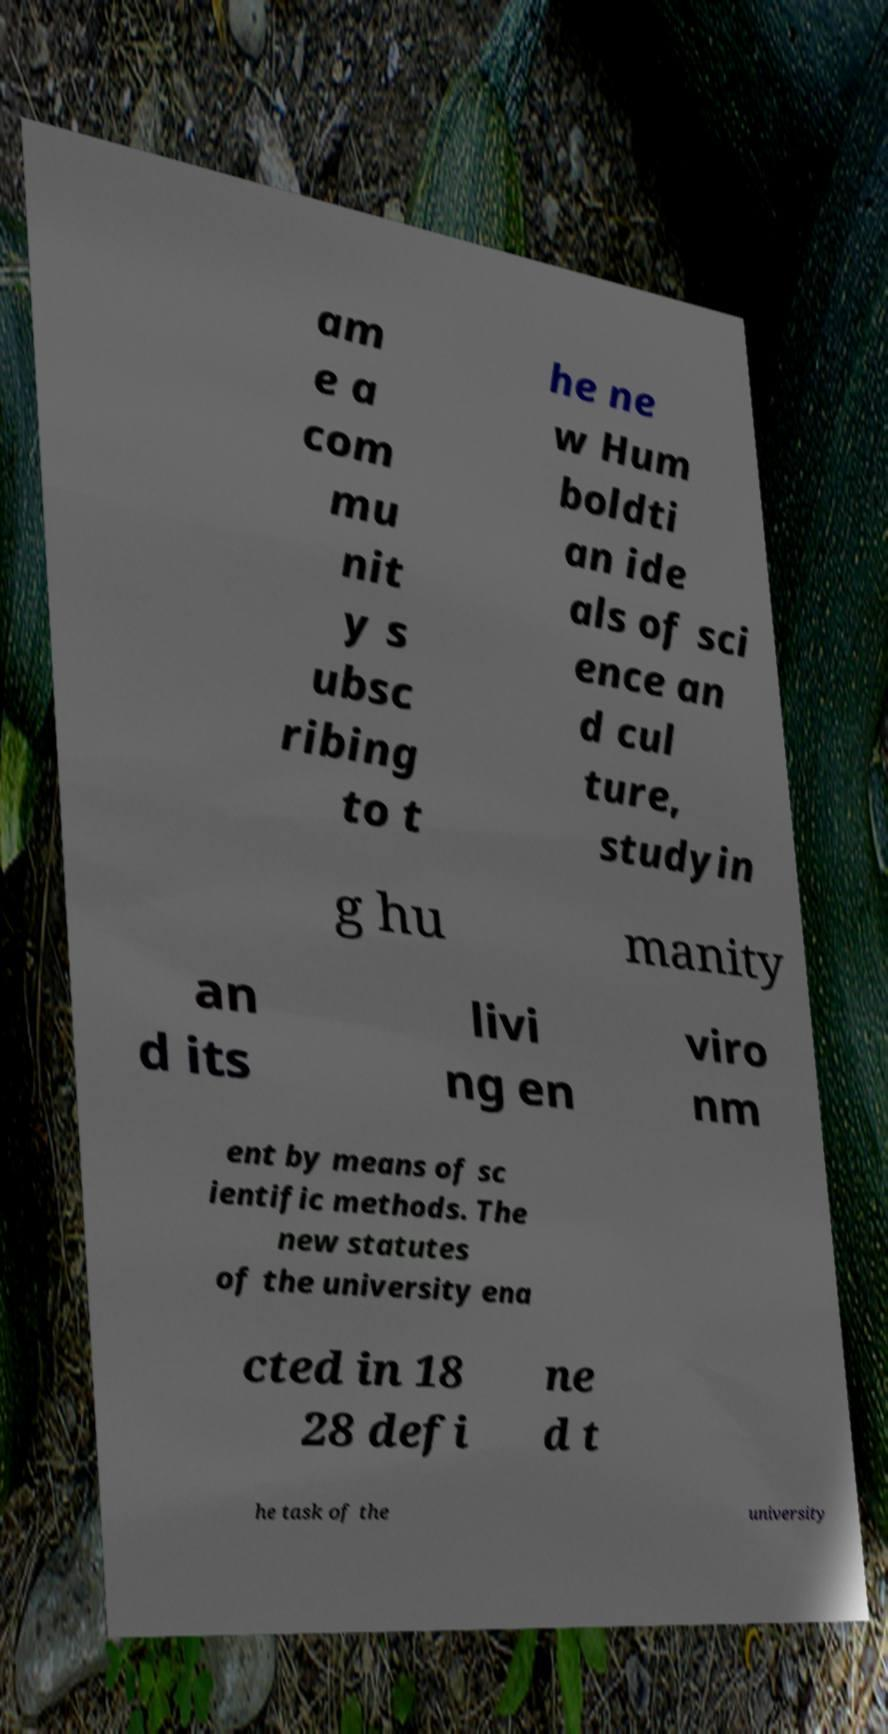Can you read and provide the text displayed in the image?This photo seems to have some interesting text. Can you extract and type it out for me? am e a com mu nit y s ubsc ribing to t he ne w Hum boldti an ide als of sci ence an d cul ture, studyin g hu manity an d its livi ng en viro nm ent by means of sc ientific methods. The new statutes of the university ena cted in 18 28 defi ne d t he task of the university 